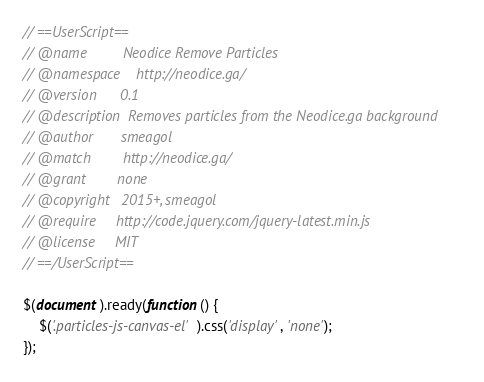Convert code to text. <code><loc_0><loc_0><loc_500><loc_500><_JavaScript_>// ==UserScript==
// @name         Neodice Remove Particles
// @namespace    http://neodice.ga/
// @version      0.1
// @description  Removes particles from the Neodice.ga background
// @author       smeagol
// @match        http://neodice.ga/
// @grant        none
// @copyright   2015+, smeagol
// @require     http://code.jquery.com/jquery-latest.min.js
// @license     MIT
// ==/UserScript==

$(document).ready(function() {
    $('.particles-js-canvas-el').css('display', 'none');
});
</code> 